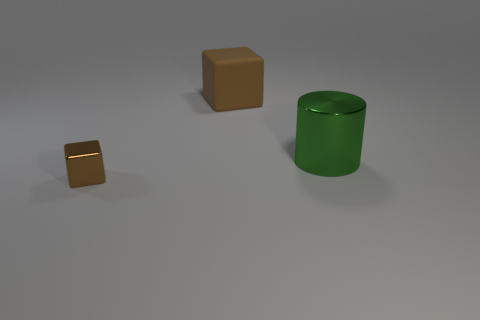Add 2 big cylinders. How many objects exist? 5 Subtract 1 cubes. How many cubes are left? 1 Subtract all cylinders. How many objects are left? 2 Add 3 brown matte cubes. How many brown matte cubes exist? 4 Subtract 0 yellow cylinders. How many objects are left? 3 Subtract all brown cylinders. Subtract all red spheres. How many cylinders are left? 1 Subtract all large brown objects. Subtract all tiny blocks. How many objects are left? 1 Add 1 large brown matte objects. How many large brown matte objects are left? 2 